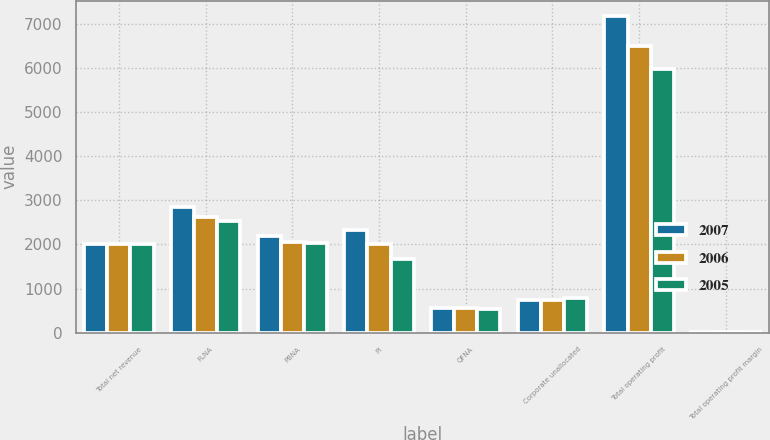<chart> <loc_0><loc_0><loc_500><loc_500><stacked_bar_chart><ecel><fcel>Total net revenue<fcel>FLNA<fcel>PBNA<fcel>PI<fcel>QFNA<fcel>Corporate unallocated<fcel>Total operating profit<fcel>Total operating profit margin<nl><fcel>2007<fcel>2016<fcel>2845<fcel>2188<fcel>2322<fcel>568<fcel>753<fcel>7170<fcel>18.2<nl><fcel>2006<fcel>2016<fcel>2615<fcel>2055<fcel>2016<fcel>554<fcel>738<fcel>6502<fcel>18.5<nl><fcel>2005<fcel>2016<fcel>2529<fcel>2037<fcel>1661<fcel>537<fcel>780<fcel>5984<fcel>18.4<nl></chart> 